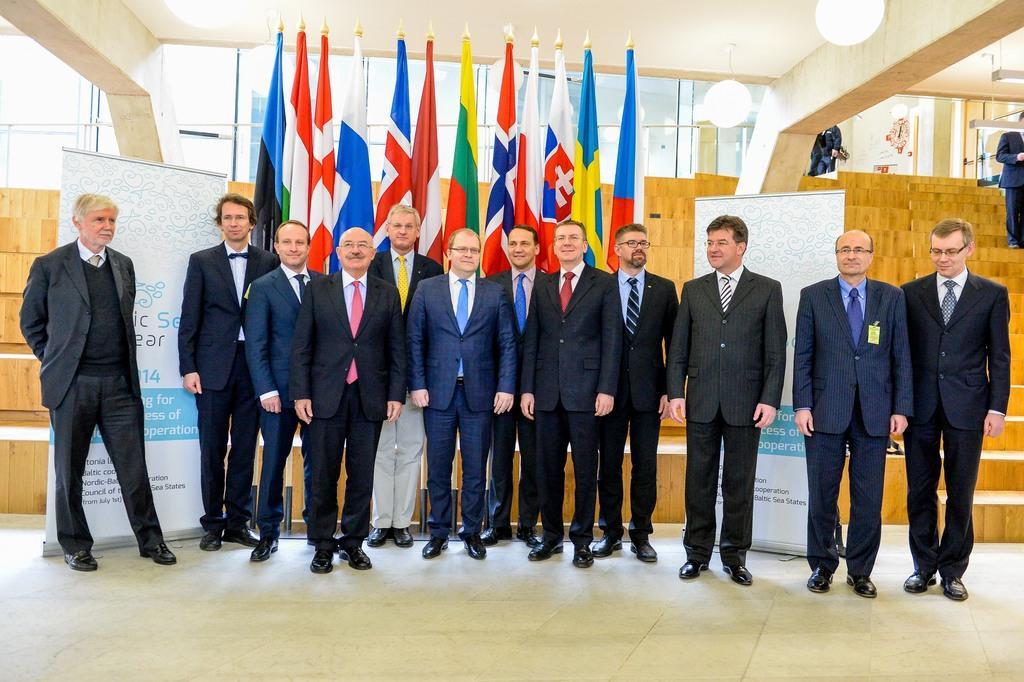In one or two sentences, can you explain what this image depicts? In this image we can see a group of people are standing. There are many flags behind the group of people. There some lamps are hanged to a roof. 